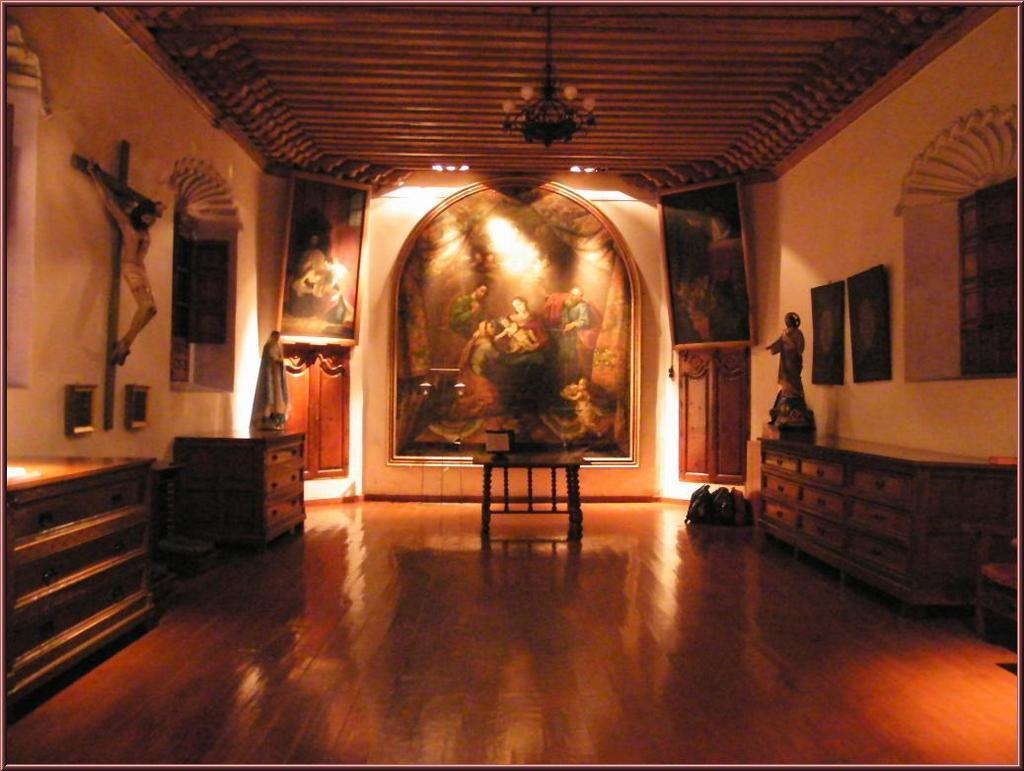What is on the wall in the image? There is a statue on the wall in the image. What piece of furniture is present in the image? There is a table in the image. What type of lighting fixture is visible in the image? There is a chandelier in the image. What type of shoes can be seen hanging from the chandelier in the image? There are no shoes present in the image, and the chandelier is not depicted as having any shoes hanging from it. 